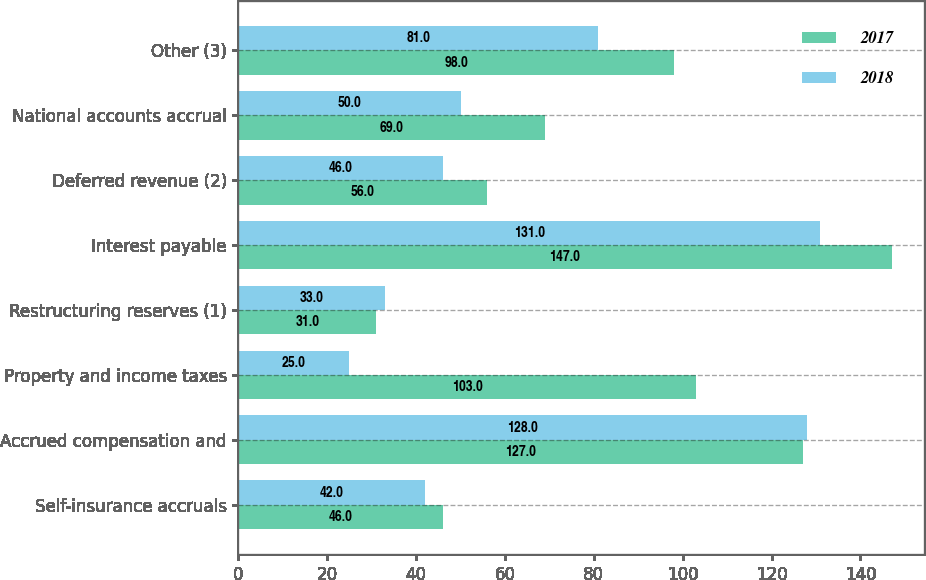Convert chart to OTSL. <chart><loc_0><loc_0><loc_500><loc_500><stacked_bar_chart><ecel><fcel>Self-insurance accruals<fcel>Accrued compensation and<fcel>Property and income taxes<fcel>Restructuring reserves (1)<fcel>Interest payable<fcel>Deferred revenue (2)<fcel>National accounts accrual<fcel>Other (3)<nl><fcel>2017<fcel>46<fcel>127<fcel>103<fcel>31<fcel>147<fcel>56<fcel>69<fcel>98<nl><fcel>2018<fcel>42<fcel>128<fcel>25<fcel>33<fcel>131<fcel>46<fcel>50<fcel>81<nl></chart> 